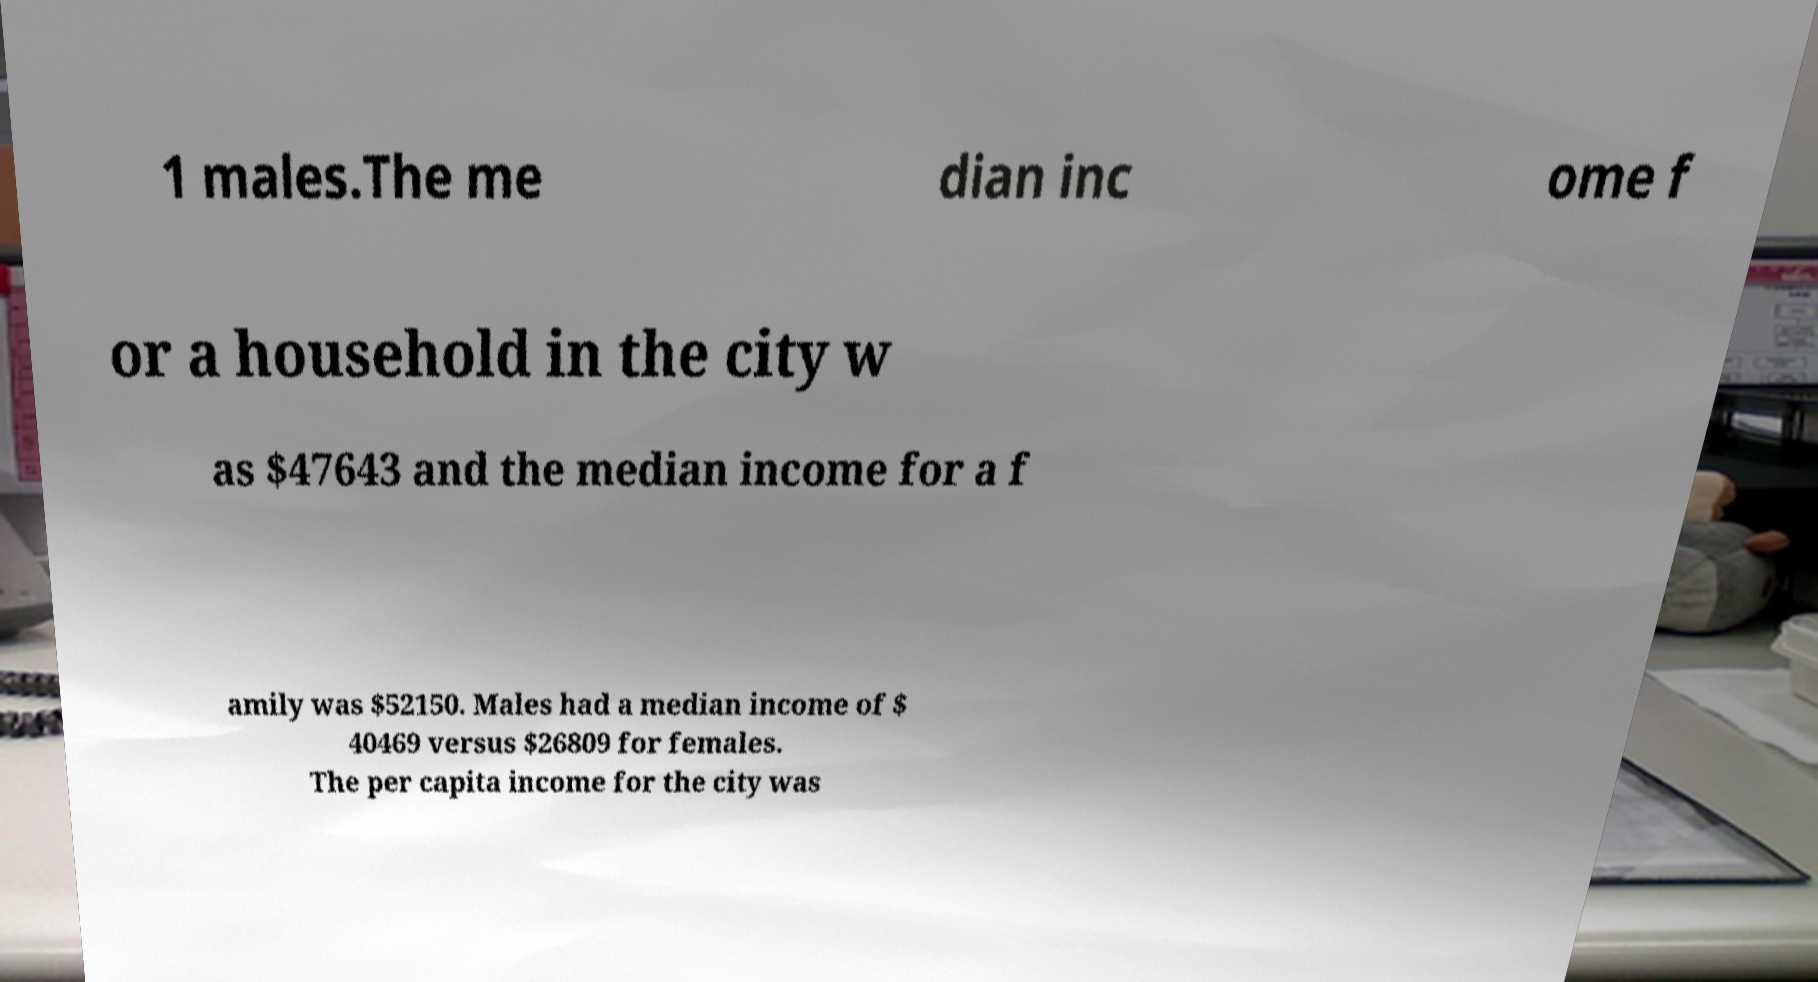Could you extract and type out the text from this image? 1 males.The me dian inc ome f or a household in the city w as $47643 and the median income for a f amily was $52150. Males had a median income of $ 40469 versus $26809 for females. The per capita income for the city was 